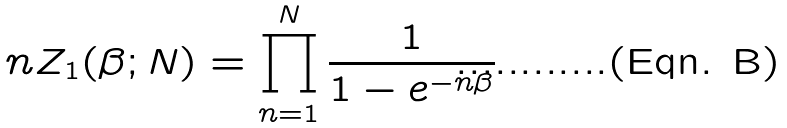<formula> <loc_0><loc_0><loc_500><loc_500>\ n Z _ { 1 } ( \beta ; N ) = \prod _ { n = 1 } ^ { N } \frac { 1 } { 1 - e ^ { - n \beta } }</formula> 